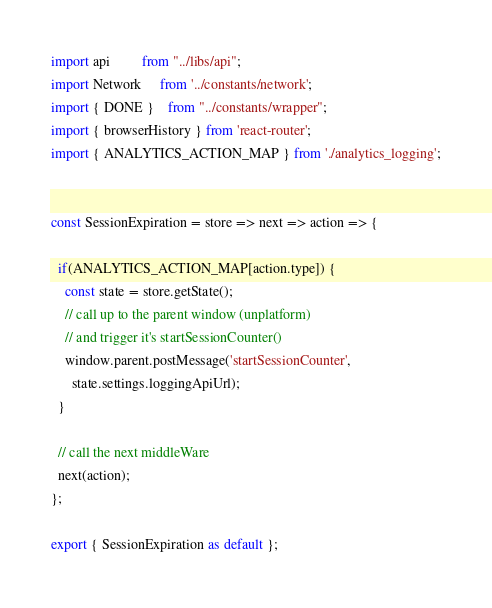<code> <loc_0><loc_0><loc_500><loc_500><_JavaScript_>import api         from "../libs/api";
import Network     from '../constants/network';
import { DONE }    from "../constants/wrapper";
import { browserHistory } from 'react-router';
import { ANALYTICS_ACTION_MAP } from './analytics_logging';


const SessionExpiration = store => next => action => {

  if(ANALYTICS_ACTION_MAP[action.type]) {
    const state = store.getState();
    // call up to the parent window (unplatform)
    // and trigger it's startSessionCounter()
    window.parent.postMessage('startSessionCounter',
      state.settings.loggingApiUrl);
  }

  // call the next middleWare
  next(action);
};

export { SessionExpiration as default };
</code> 